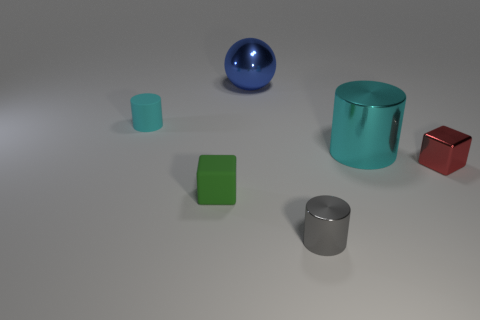How many metal things have the same size as the matte cylinder?
Provide a short and direct response. 2. What is the ball made of?
Give a very brief answer. Metal. Are there more large purple matte objects than red things?
Keep it short and to the point. No. Do the tiny green thing and the cyan metal thing have the same shape?
Offer a very short reply. No. Are there any other things that are the same shape as the tiny green matte object?
Make the answer very short. Yes. There is a small metal thing that is in front of the red metal object; is its color the same as the object left of the tiny rubber block?
Offer a terse response. No. Are there fewer green rubber blocks that are in front of the green cube than tiny metallic cubes behind the tiny cyan object?
Ensure brevity in your answer.  No. There is a blue metallic thing that is behind the green object; what is its shape?
Keep it short and to the point. Sphere. There is a thing that is the same color as the large cylinder; what is its material?
Provide a succinct answer. Rubber. What number of other things are made of the same material as the small cyan cylinder?
Ensure brevity in your answer.  1. 